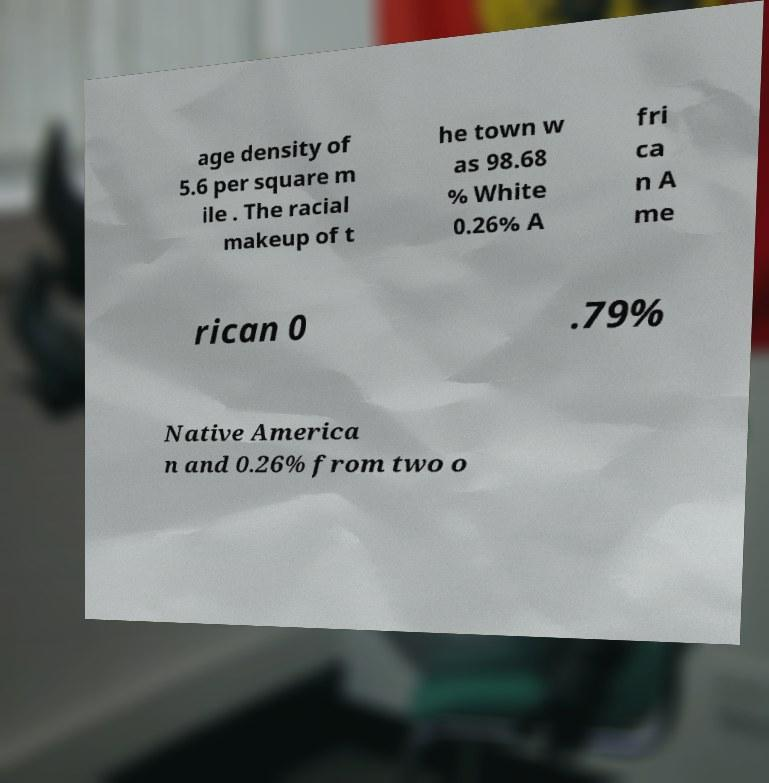I need the written content from this picture converted into text. Can you do that? age density of 5.6 per square m ile . The racial makeup of t he town w as 98.68 % White 0.26% A fri ca n A me rican 0 .79% Native America n and 0.26% from two o 